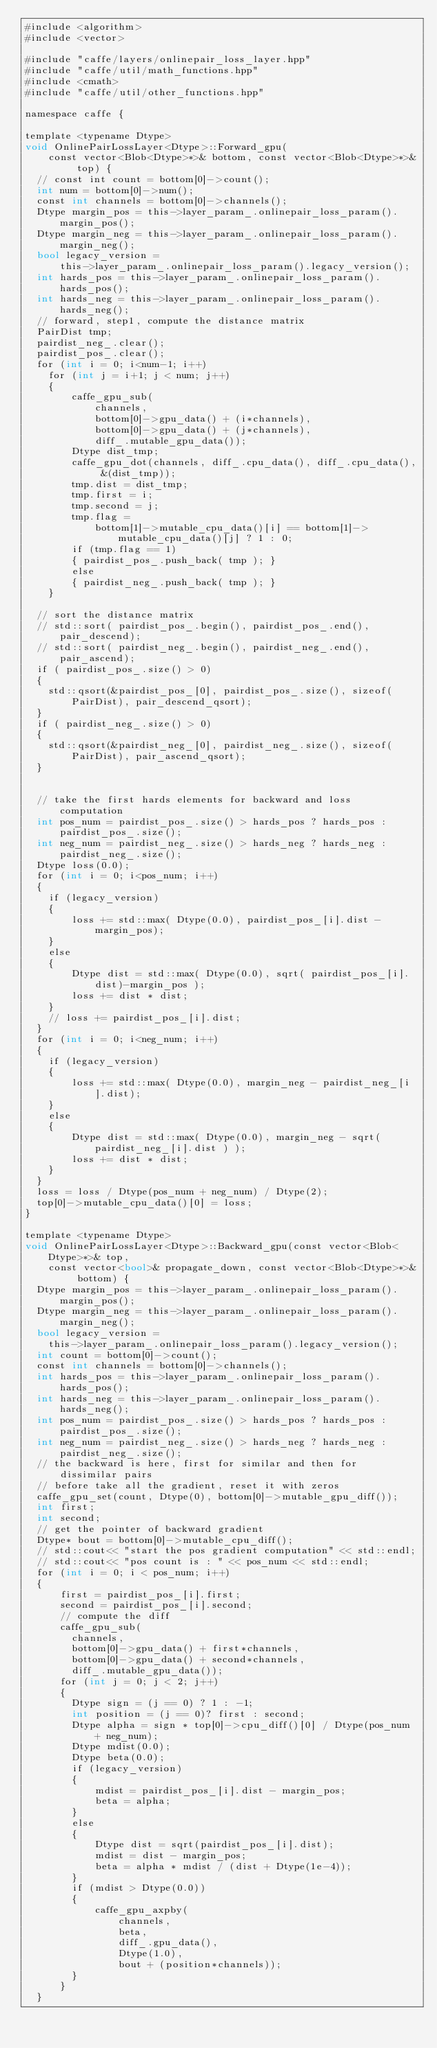Convert code to text. <code><loc_0><loc_0><loc_500><loc_500><_Cuda_>#include <algorithm>
#include <vector>

#include "caffe/layers/onlinepair_loss_layer.hpp"
#include "caffe/util/math_functions.hpp"
#include <cmath>
#include "caffe/util/other_functions.hpp"

namespace caffe {

template <typename Dtype>
void OnlinePairLossLayer<Dtype>::Forward_gpu(
    const vector<Blob<Dtype>*>& bottom, const vector<Blob<Dtype>*>& top) {
  // const int count = bottom[0]->count();
  int num = bottom[0]->num();
  const int channels = bottom[0]->channels();
  Dtype margin_pos = this->layer_param_.onlinepair_loss_param().margin_pos();
  Dtype margin_neg = this->layer_param_.onlinepair_loss_param().margin_neg();
  bool legacy_version =
      this->layer_param_.onlinepair_loss_param().legacy_version();
  int hards_pos = this->layer_param_.onlinepair_loss_param().hards_pos();
  int hards_neg = this->layer_param_.onlinepair_loss_param().hards_neg();
  // forward, step1, compute the distance matrix
  PairDist tmp;
  pairdist_neg_.clear();
  pairdist_pos_.clear();
  for (int i = 0; i<num-1; i++)
    for (int j = i+1; j < num; j++)
    {
        caffe_gpu_sub(
            channels, 
            bottom[0]->gpu_data() + (i*channels),
            bottom[0]->gpu_data() + (j*channels),
            diff_.mutable_gpu_data());
        Dtype dist_tmp;
        caffe_gpu_dot(channels, diff_.cpu_data(), diff_.cpu_data(), &(dist_tmp));
        tmp.dist = dist_tmp; 
        tmp.first = i;
        tmp.second = j;
        tmp.flag = 
            bottom[1]->mutable_cpu_data()[i] == bottom[1]->mutable_cpu_data()[j] ? 1 : 0;
        if (tmp.flag == 1)
        { pairdist_pos_.push_back( tmp ); }
        else
        { pairdist_neg_.push_back( tmp ); }
    }

  // sort the distance matrix
  // std::sort( pairdist_pos_.begin(), pairdist_pos_.end(), pair_descend);
  // std::sort( pairdist_neg_.begin(), pairdist_neg_.end(), pair_ascend);
  if ( pairdist_pos_.size() > 0) 
  {
    std::qsort(&pairdist_pos_[0], pairdist_pos_.size(), sizeof(PairDist), pair_descend_qsort);
  }
  if ( pairdist_neg_.size() > 0)
  {
    std::qsort(&pairdist_neg_[0], pairdist_neg_.size(), sizeof(PairDist), pair_ascend_qsort); 
  }


  // take the first hards elements for backward and loss computation
  int pos_num = pairdist_pos_.size() > hards_pos ? hards_pos : pairdist_pos_.size();
  int neg_num = pairdist_neg_.size() > hards_neg ? hards_neg : pairdist_neg_.size();
  Dtype loss(0.0);
  for (int i = 0; i<pos_num; i++)
  {
    if (legacy_version)
    {
        loss += std::max( Dtype(0.0), pairdist_pos_[i].dist - margin_pos);
    }
    else
    {
        Dtype dist = std::max( Dtype(0.0), sqrt( pairdist_pos_[i].dist)-margin_pos );
        loss += dist * dist;
    }
    // loss += pairdist_pos_[i].dist;
  }
  for (int i = 0; i<neg_num; i++)
  {
    if (legacy_version) 
    {
        loss += std::max( Dtype(0.0), margin_neg - pairdist_neg_[i].dist);
    }
    else
    {
        Dtype dist = std::max( Dtype(0.0), margin_neg - sqrt( pairdist_neg_[i].dist ) );
        loss += dist * dist;
    }
  }
  loss = loss / Dtype(pos_num + neg_num) / Dtype(2);
  top[0]->mutable_cpu_data()[0] = loss;
}

template <typename Dtype>
void OnlinePairLossLayer<Dtype>::Backward_gpu(const vector<Blob<Dtype>*>& top,
    const vector<bool>& propagate_down, const vector<Blob<Dtype>*>& bottom) {
  Dtype margin_pos = this->layer_param_.onlinepair_loss_param().margin_pos();
  Dtype margin_neg = this->layer_param_.onlinepair_loss_param().margin_neg();
  bool legacy_version =
    this->layer_param_.onlinepair_loss_param().legacy_version();
  int count = bottom[0]->count();
  const int channels = bottom[0]->channels();
  int hards_pos = this->layer_param_.onlinepair_loss_param().hards_pos();
  int hards_neg = this->layer_param_.onlinepair_loss_param().hards_neg();
  int pos_num = pairdist_pos_.size() > hards_pos ? hards_pos : pairdist_pos_.size();
  int neg_num = pairdist_neg_.size() > hards_neg ? hards_neg : pairdist_neg_.size();
  // the backward is here, first for similar and then for dissimilar pairs
  // before take all the gradient, reset it with zeros
  caffe_gpu_set(count, Dtype(0), bottom[0]->mutable_gpu_diff());
  int first;
  int second;
  // get the pointer of backward gradient
  Dtype* bout = bottom[0]->mutable_cpu_diff();
  // std::cout<< "start the pos gradient computation" << std::endl;
  // std::cout<< "pos count is : " << pos_num << std::endl;
  for (int i = 0; i < pos_num; i++)
  {
      first = pairdist_pos_[i].first;
      second = pairdist_pos_[i].second;
      // compute the diff 
      caffe_gpu_sub(
        channels,
        bottom[0]->gpu_data() + first*channels,
        bottom[0]->gpu_data() + second*channels,
        diff_.mutable_gpu_data());
      for (int j = 0; j < 2; j++)
      {
        Dtype sign = (j == 0) ? 1 : -1;
        int position = (j == 0)? first : second;
        Dtype alpha = sign * top[0]->cpu_diff()[0] / Dtype(pos_num + neg_num);
        Dtype mdist(0.0);
        Dtype beta(0.0);
        if (legacy_version)
        {
            mdist = pairdist_pos_[i].dist - margin_pos;
            beta = alpha;
        }
        else
        {
            Dtype dist = sqrt(pairdist_pos_[i].dist);
            mdist = dist - margin_pos;
            beta = alpha * mdist / (dist + Dtype(1e-4)); 
        }
        if (mdist > Dtype(0.0))
        {
            caffe_gpu_axpby(
                channels,
                beta,
                diff_.gpu_data(),
                Dtype(1.0),
                bout + (position*channels));
        }
      }
  }</code> 